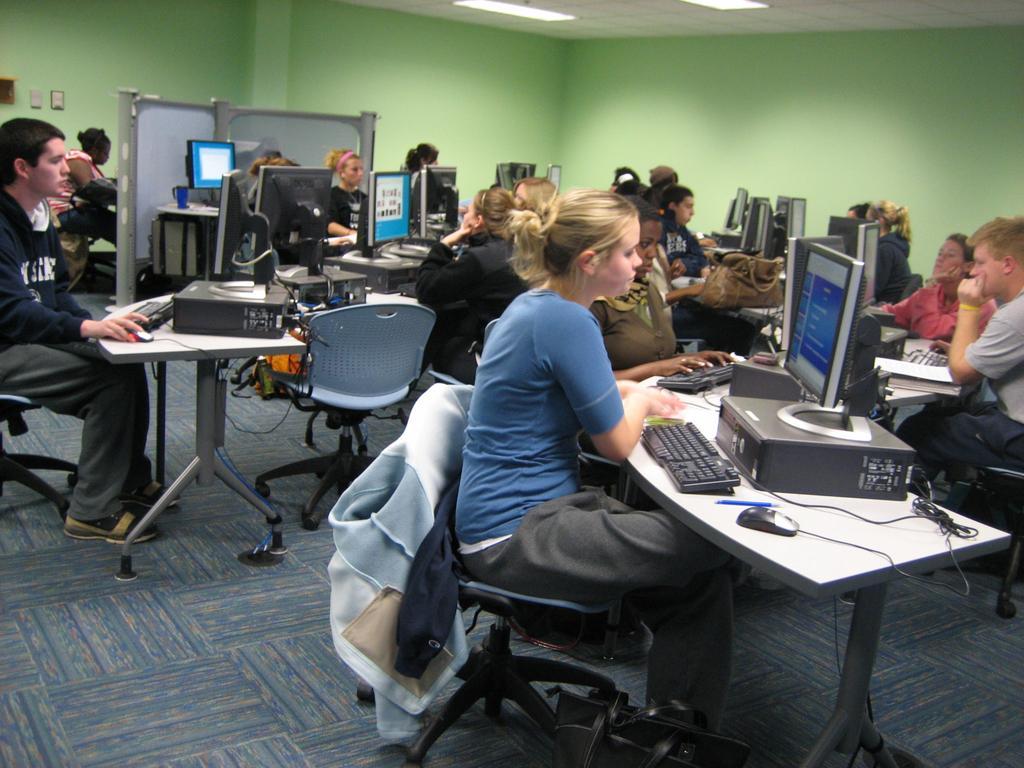How would you summarize this image in a sentence or two? There are so many people sitting in a room operating computers. 